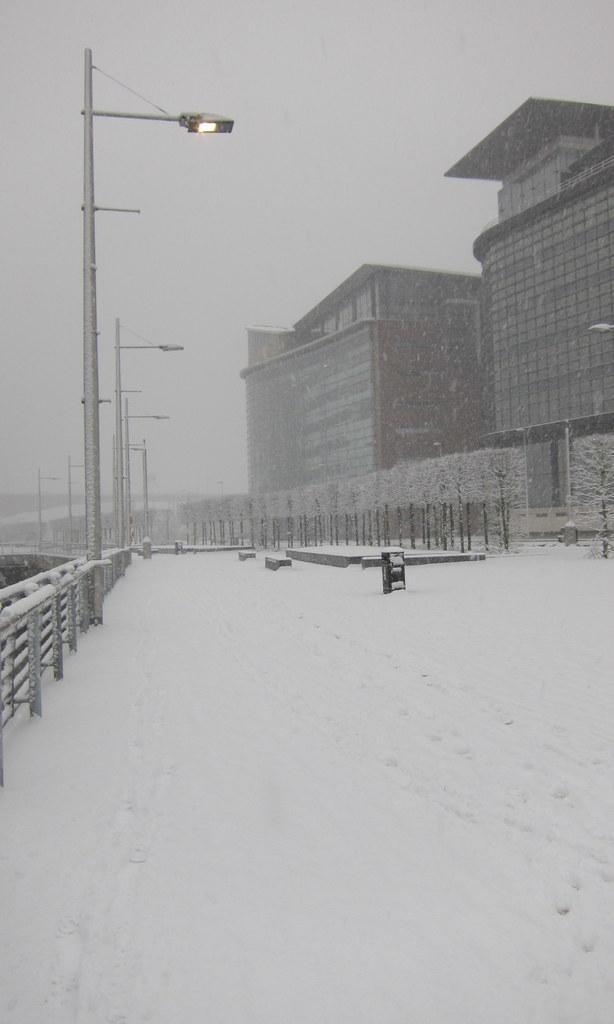In one or two sentences, can you explain what this image depicts? In this image, we can see street lights, railing, snow, plants, buildings and few objects. In the background, there is the sky. 